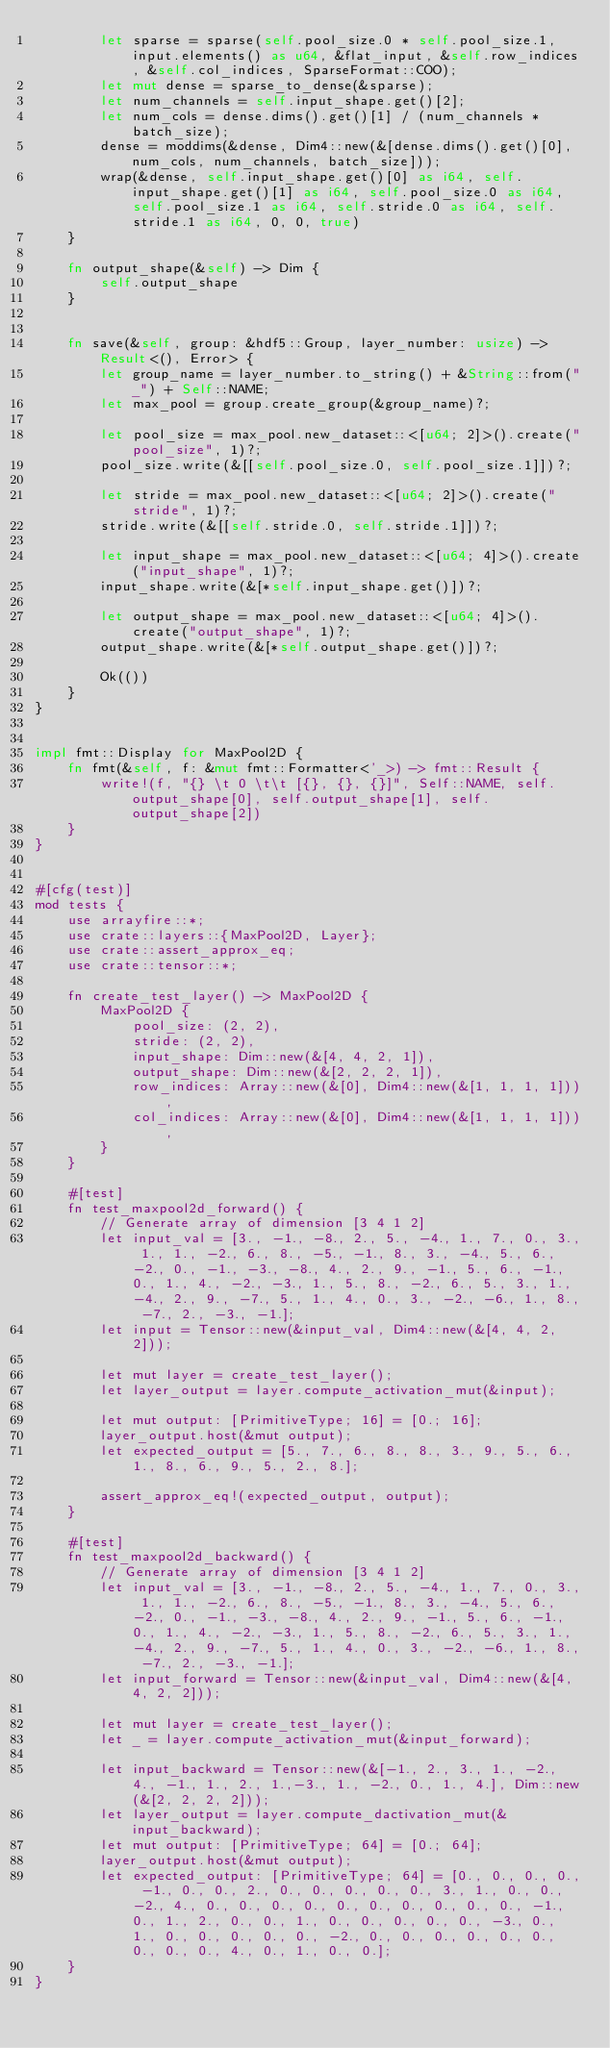<code> <loc_0><loc_0><loc_500><loc_500><_Rust_>        let sparse = sparse(self.pool_size.0 * self.pool_size.1, input.elements() as u64, &flat_input, &self.row_indices, &self.col_indices, SparseFormat::COO);
        let mut dense = sparse_to_dense(&sparse);
        let num_channels = self.input_shape.get()[2];
        let num_cols = dense.dims().get()[1] / (num_channels * batch_size);
        dense = moddims(&dense, Dim4::new(&[dense.dims().get()[0], num_cols, num_channels, batch_size]));
        wrap(&dense, self.input_shape.get()[0] as i64, self.input_shape.get()[1] as i64, self.pool_size.0 as i64, self.pool_size.1 as i64, self.stride.0 as i64, self.stride.1 as i64, 0, 0, true)
    }

    fn output_shape(&self) -> Dim {
        self.output_shape
    }


    fn save(&self, group: &hdf5::Group, layer_number: usize) -> Result<(), Error> {
        let group_name = layer_number.to_string() + &String::from("_") + Self::NAME;
        let max_pool = group.create_group(&group_name)?;

        let pool_size = max_pool.new_dataset::<[u64; 2]>().create("pool_size", 1)?;
        pool_size.write(&[[self.pool_size.0, self.pool_size.1]])?;

        let stride = max_pool.new_dataset::<[u64; 2]>().create("stride", 1)?;
        stride.write(&[[self.stride.0, self.stride.1]])?;

        let input_shape = max_pool.new_dataset::<[u64; 4]>().create("input_shape", 1)?;
        input_shape.write(&[*self.input_shape.get()])?;

        let output_shape = max_pool.new_dataset::<[u64; 4]>().create("output_shape", 1)?;
        output_shape.write(&[*self.output_shape.get()])?;

        Ok(())
    }
}


impl fmt::Display for MaxPool2D {
    fn fmt(&self, f: &mut fmt::Formatter<'_>) -> fmt::Result {
        write!(f, "{} \t 0 \t\t [{}, {}, {}]", Self::NAME, self.output_shape[0], self.output_shape[1], self.output_shape[2])
    }
}


#[cfg(test)]
mod tests {
    use arrayfire::*;
    use crate::layers::{MaxPool2D, Layer};
    use crate::assert_approx_eq;
    use crate::tensor::*;

    fn create_test_layer() -> MaxPool2D {
        MaxPool2D {
            pool_size: (2, 2),
            stride: (2, 2),
            input_shape: Dim::new(&[4, 4, 2, 1]),
            output_shape: Dim::new(&[2, 2, 2, 1]),
            row_indices: Array::new(&[0], Dim4::new(&[1, 1, 1, 1])),
            col_indices: Array::new(&[0], Dim4::new(&[1, 1, 1, 1])),
        }
    }

    #[test]
    fn test_maxpool2d_forward() {
        // Generate array of dimension [3 4 1 2]
        let input_val = [3., -1., -8., 2., 5., -4., 1., 7., 0., 3., 1., 1., -2., 6., 8., -5., -1., 8., 3., -4., 5., 6., -2., 0., -1., -3., -8., 4., 2., 9., -1., 5., 6., -1., 0., 1., 4., -2., -3., 1., 5., 8., -2., 6., 5., 3., 1., -4., 2., 9., -7., 5., 1., 4., 0., 3., -2., -6., 1., 8., -7., 2., -3., -1.];
        let input = Tensor::new(&input_val, Dim4::new(&[4, 4, 2, 2]));

        let mut layer = create_test_layer();
        let layer_output = layer.compute_activation_mut(&input);

        let mut output: [PrimitiveType; 16] = [0.; 16];
        layer_output.host(&mut output);
        let expected_output = [5., 7., 6., 8., 8., 3., 9., 5., 6., 1., 8., 6., 9., 5., 2., 8.];

        assert_approx_eq!(expected_output, output);
    }

    #[test]
    fn test_maxpool2d_backward() {
        // Generate array of dimension [3 4 1 2]
        let input_val = [3., -1., -8., 2., 5., -4., 1., 7., 0., 3., 1., 1., -2., 6., 8., -5., -1., 8., 3., -4., 5., 6., -2., 0., -1., -3., -8., 4., 2., 9., -1., 5., 6., -1., 0., 1., 4., -2., -3., 1., 5., 8., -2., 6., 5., 3., 1., -4., 2., 9., -7., 5., 1., 4., 0., 3., -2., -6., 1., 8., -7., 2., -3., -1.];
        let input_forward = Tensor::new(&input_val, Dim4::new(&[4, 4, 2, 2]));

        let mut layer = create_test_layer();
        let _ = layer.compute_activation_mut(&input_forward);

        let input_backward = Tensor::new(&[-1., 2., 3., 1., -2., 4., -1., 1., 2., 1.,-3., 1., -2., 0., 1., 4.], Dim::new(&[2, 2, 2, 2]));
        let layer_output = layer.compute_dactivation_mut(&input_backward);
        let mut output: [PrimitiveType; 64] = [0.; 64];
        layer_output.host(&mut output);
        let expected_output: [PrimitiveType; 64] = [0., 0., 0., 0., -1., 0., 0., 2., 0., 0., 0., 0., 0., 3., 1., 0., 0., -2., 4., 0., 0., 0., 0., 0., 0., 0., 0., 0., 0., -1., 0., 1., 2., 0., 0., 1., 0., 0., 0., 0., 0., -3., 0., 1., 0., 0., 0., 0., 0., -2., 0., 0., 0., 0., 0., 0., 0., 0., 0., 4., 0., 1., 0., 0.];
    }
}
</code> 